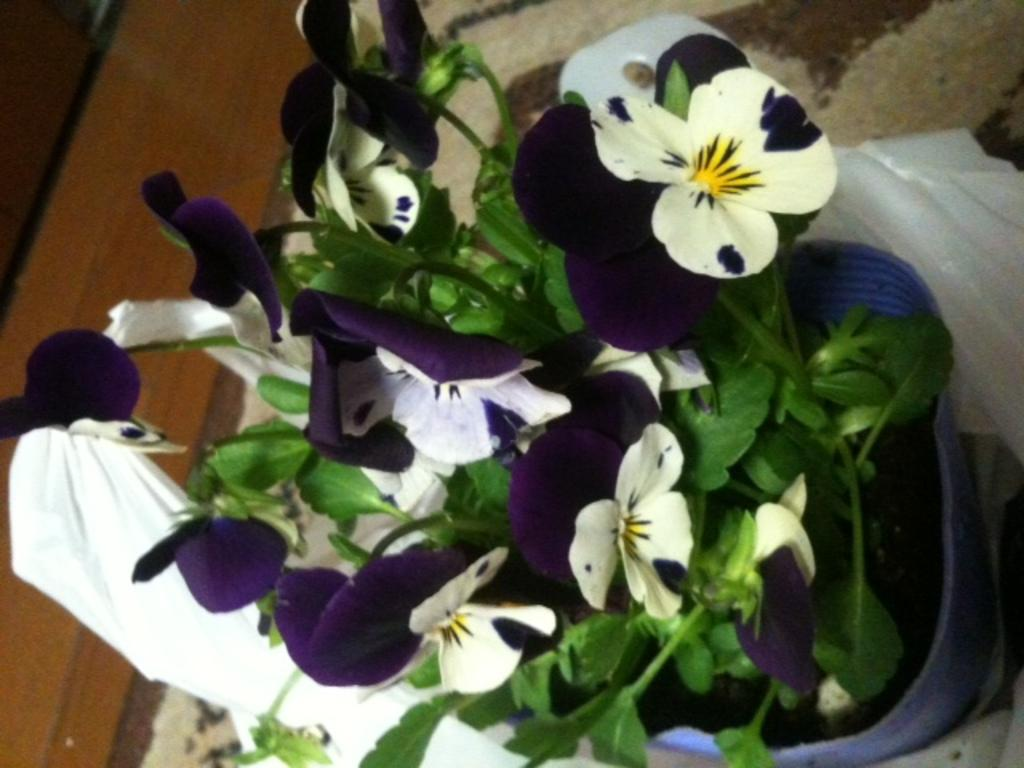What object is in the image that holds flowers? There is a flower vase in the image. Where is the flower vase positioned in the image? The flower vase is placed on a stand. What can be seen in the background of the image? There is a cloth in the background of the image. What is located on the left side of the image? There is a wooden block on the left side of the image. What type of muscle is visible in the image? There is no muscle visible in the image; it features a flower vase, a stand, a cloth, and a wooden block. 